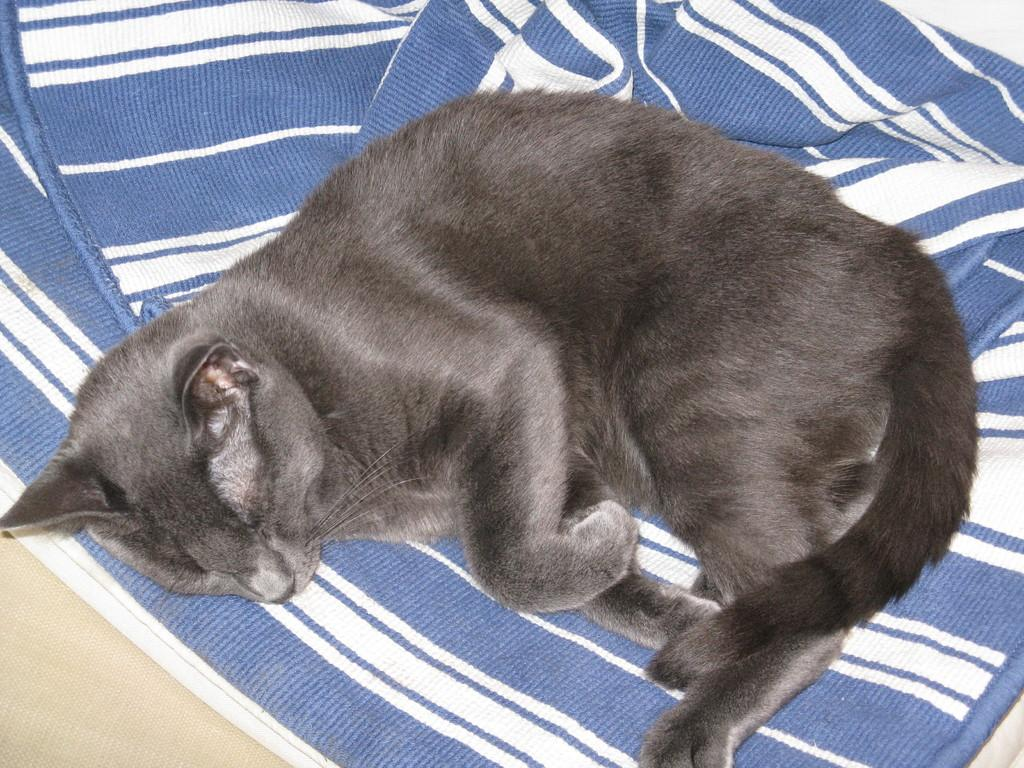What type of animal is in the image? There is a cat in the image. What is the cat doing in the image? The cat is sleeping. Where is the cat located in the image? The cat is on a bed. What channel is the cat watching on the television in the image? There is no television present in the image, so the cat cannot be watching any channel. 